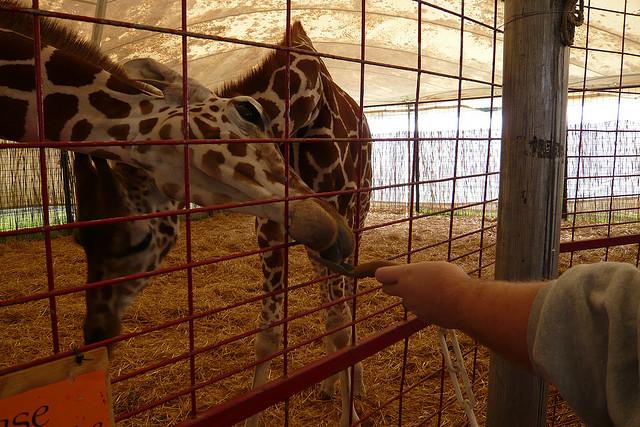How many giraffe are there?
Short answer required. 2. Is one giraffe nibbling on a paper attached to the fence?
Concise answer only. No. Why is the giraffe behind bars?
Give a very brief answer. Zoo. Are the giraffes eating from the person's hand?
Concise answer only. Yes. 